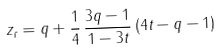<formula> <loc_0><loc_0><loc_500><loc_500>z _ { r } = q + \frac { 1 } { 4 } \, \frac { 3 q - 1 } { 1 - 3 t } \, ( 4 t - q - 1 )</formula> 